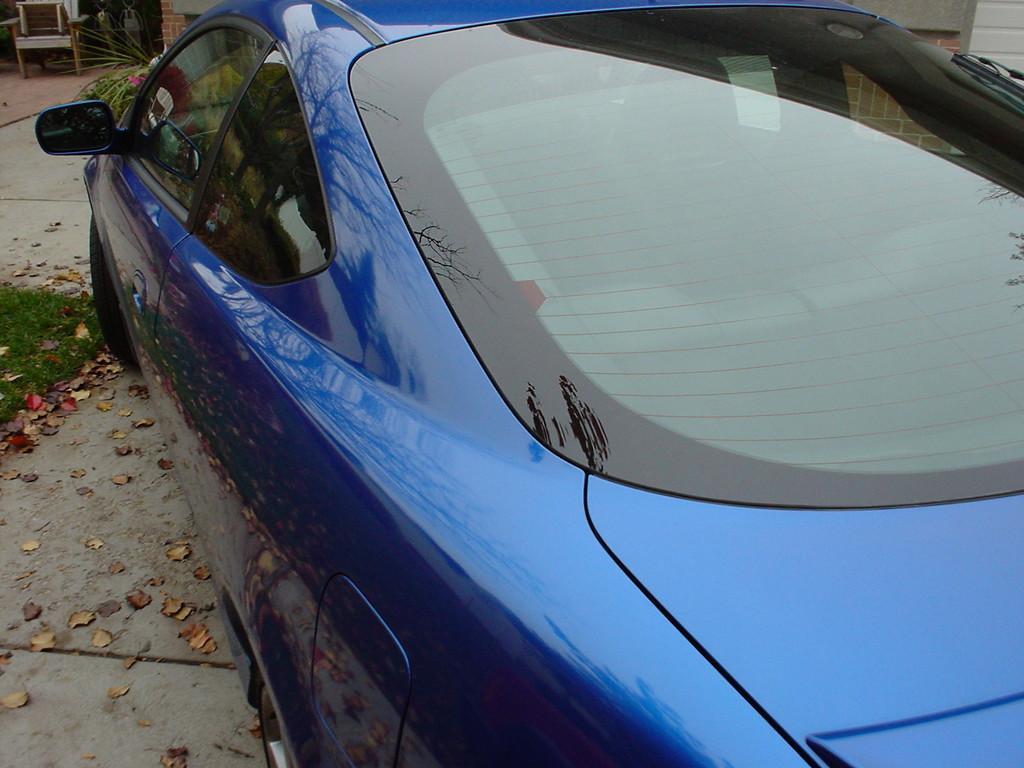Describe this image in one or two sentences. As we can see in the image there is a car on road. 